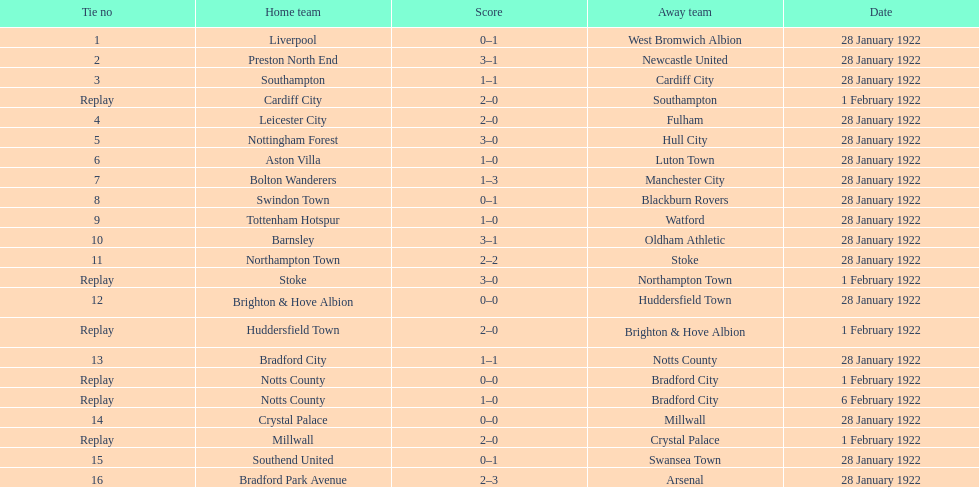Which home team had an equal score as aston villa on january 28th, 1922? Tottenham Hotspur. 